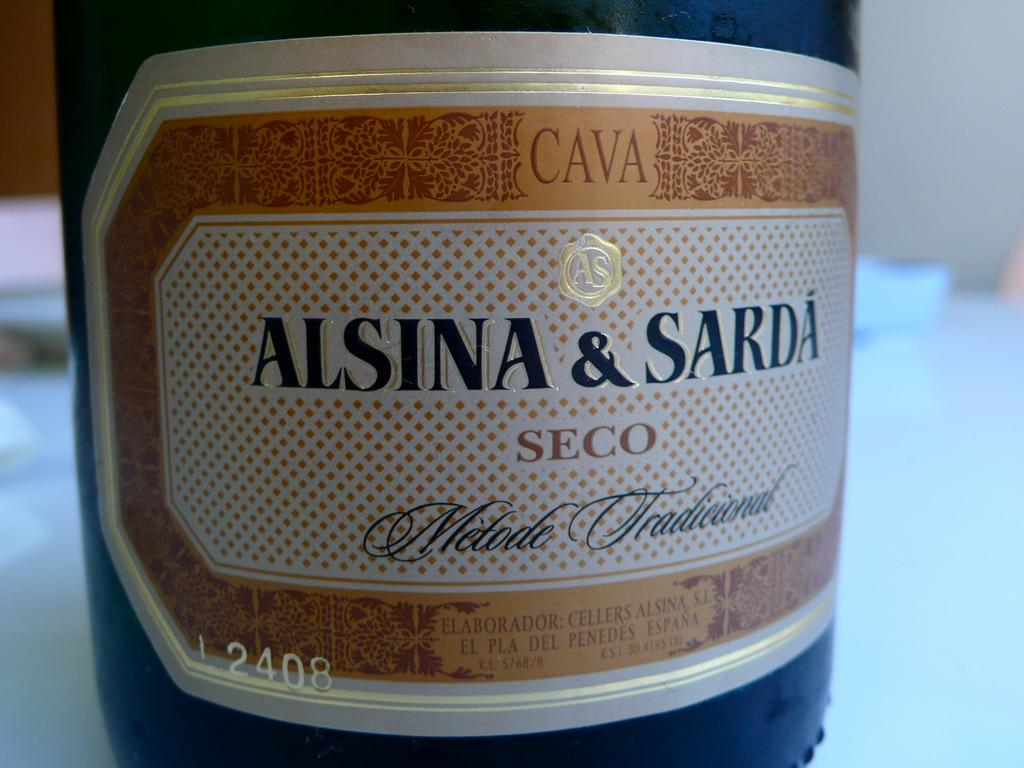<image>
Give a short and clear explanation of the subsequent image. A close up of the label of a bottle of Alsina and Sardi 